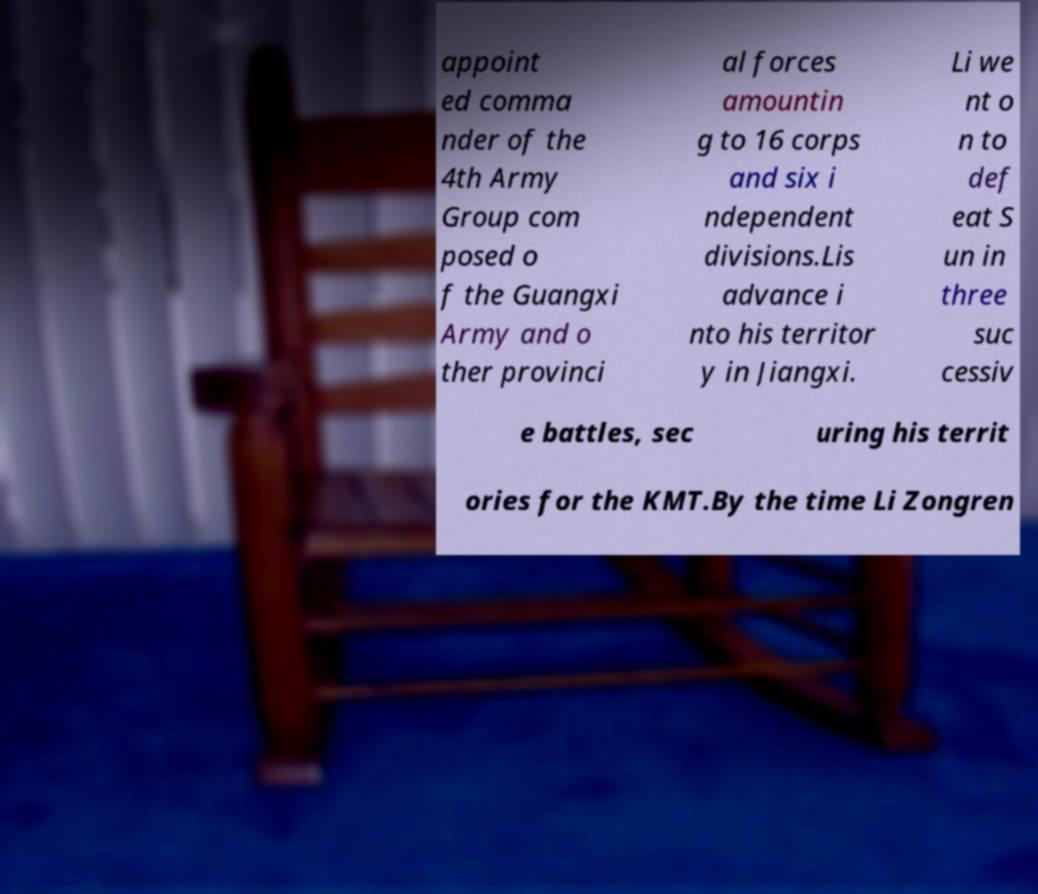I need the written content from this picture converted into text. Can you do that? appoint ed comma nder of the 4th Army Group com posed o f the Guangxi Army and o ther provinci al forces amountin g to 16 corps and six i ndependent divisions.Lis advance i nto his territor y in Jiangxi. Li we nt o n to def eat S un in three suc cessiv e battles, sec uring his territ ories for the KMT.By the time Li Zongren 